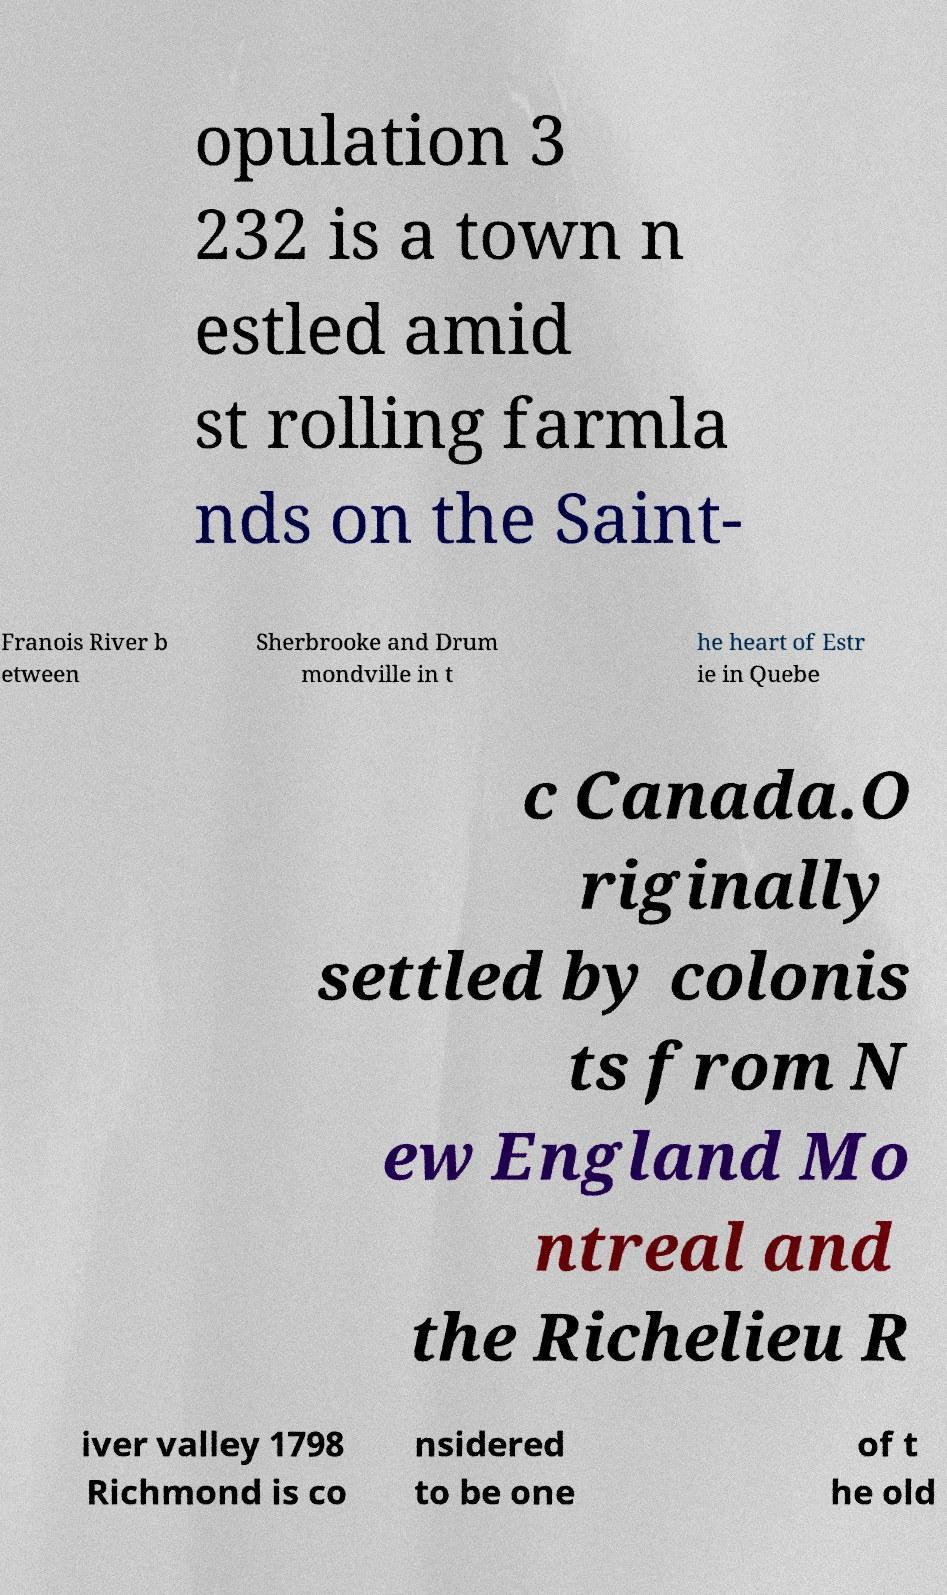I need the written content from this picture converted into text. Can you do that? opulation 3 232 is a town n estled amid st rolling farmla nds on the Saint- Franois River b etween Sherbrooke and Drum mondville in t he heart of Estr ie in Quebe c Canada.O riginally settled by colonis ts from N ew England Mo ntreal and the Richelieu R iver valley 1798 Richmond is co nsidered to be one of t he old 